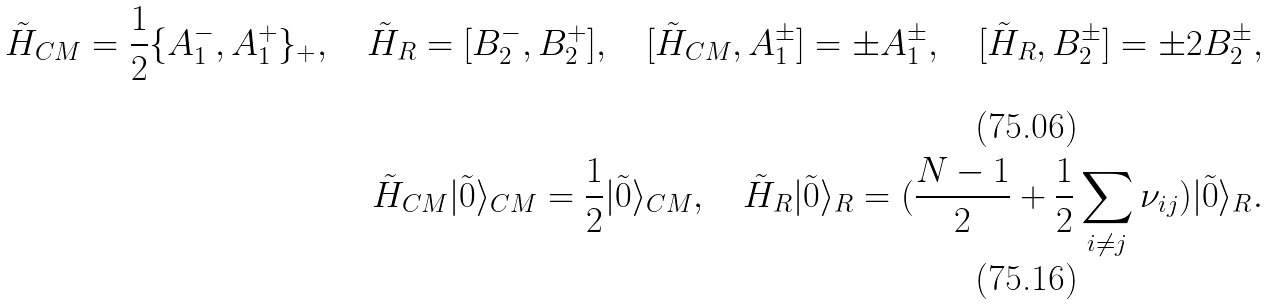<formula> <loc_0><loc_0><loc_500><loc_500>\tilde { H } _ { C M } = \frac { 1 } { 2 } \{ A _ { 1 } ^ { - } , A _ { 1 } ^ { + } \} _ { + } , \quad \tilde { H } _ { R } = [ B _ { 2 } ^ { - } , B _ { 2 } ^ { + } ] , \quad [ \tilde { H } _ { C M } , A _ { 1 } ^ { \pm } ] = \pm A _ { 1 } ^ { \pm } , \quad [ \tilde { H } _ { R } , B _ { 2 } ^ { \pm } ] = \pm 2 B _ { 2 } ^ { \pm } , \\ \tilde { H } _ { C M } | \tilde { 0 } \rangle _ { C M } = \frac { 1 } { 2 } | \tilde { 0 } \rangle _ { C M } , \quad \tilde { H } _ { R } | \tilde { 0 } \rangle _ { R } = ( \frac { N - 1 } { 2 } + \frac { 1 } { 2 } \sum _ { i \neq j } \nu _ { i j } ) | \tilde { 0 } \rangle _ { R } .</formula> 